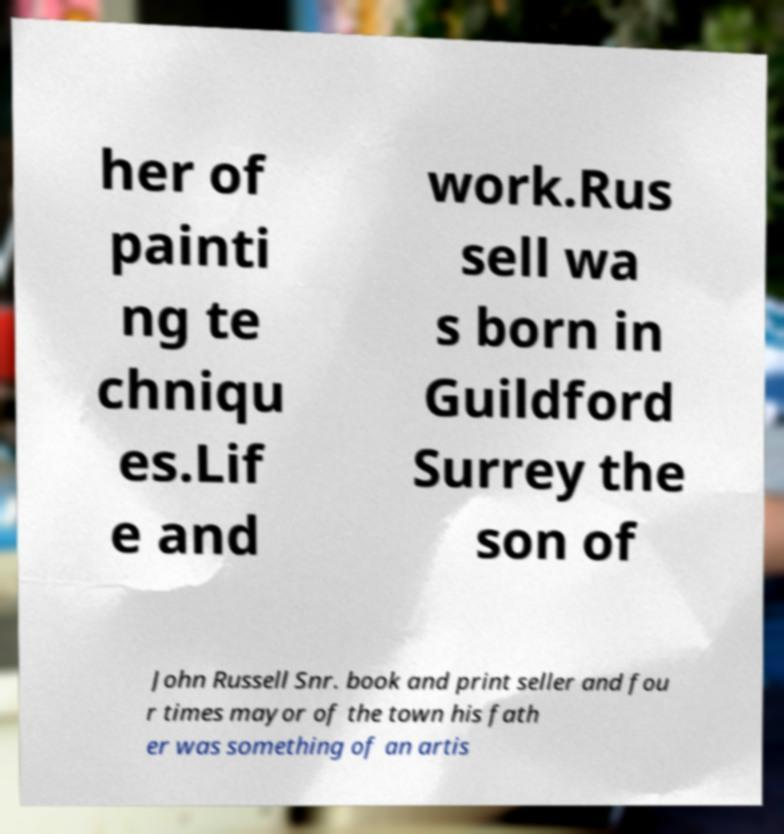Can you accurately transcribe the text from the provided image for me? her of painti ng te chniqu es.Lif e and work.Rus sell wa s born in Guildford Surrey the son of John Russell Snr. book and print seller and fou r times mayor of the town his fath er was something of an artis 